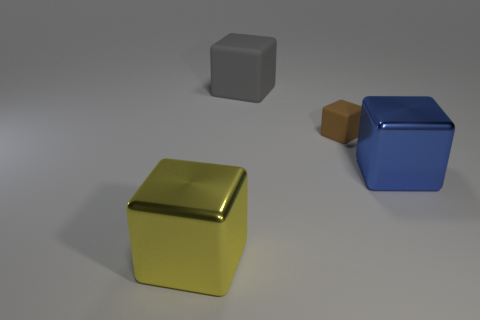Is there anything else that has the same size as the brown rubber object?
Your response must be concise. No. There is a metallic thing on the left side of the big cube that is right of the small object; what shape is it?
Offer a very short reply. Cube. Is the size of the metal object that is right of the large matte cube the same as the matte cube that is right of the large gray thing?
Offer a very short reply. No. Are there any large blue things made of the same material as the yellow thing?
Make the answer very short. Yes. There is a shiny block that is on the left side of the metal object behind the yellow shiny cube; is there a big gray rubber object that is to the left of it?
Ensure brevity in your answer.  No. Are there any tiny rubber cubes behind the yellow shiny thing?
Provide a short and direct response. Yes. What number of tiny rubber things are in front of the large metallic object to the left of the blue thing?
Your answer should be very brief. 0. Do the yellow thing and the rubber block on the right side of the large gray thing have the same size?
Offer a terse response. No. There is a gray thing that is made of the same material as the small brown object; what size is it?
Keep it short and to the point. Large. Do the large gray thing and the large blue cube have the same material?
Provide a short and direct response. No. 